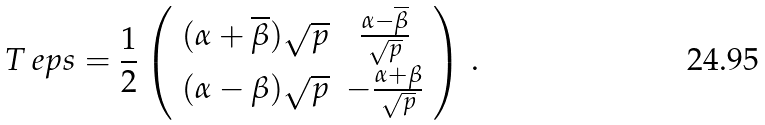<formula> <loc_0><loc_0><loc_500><loc_500>T _ { \ } e p s = \frac { 1 } { 2 } \left ( \begin{array} { c c } ( \alpha + \overline { \beta } ) \sqrt { p } & \frac { \alpha - \overline { \beta } } { \sqrt { p } } \\ ( \alpha - \beta ) \sqrt { p } & - \frac { \alpha + \beta } { \sqrt { p } } \end{array} \right ) \, .</formula> 